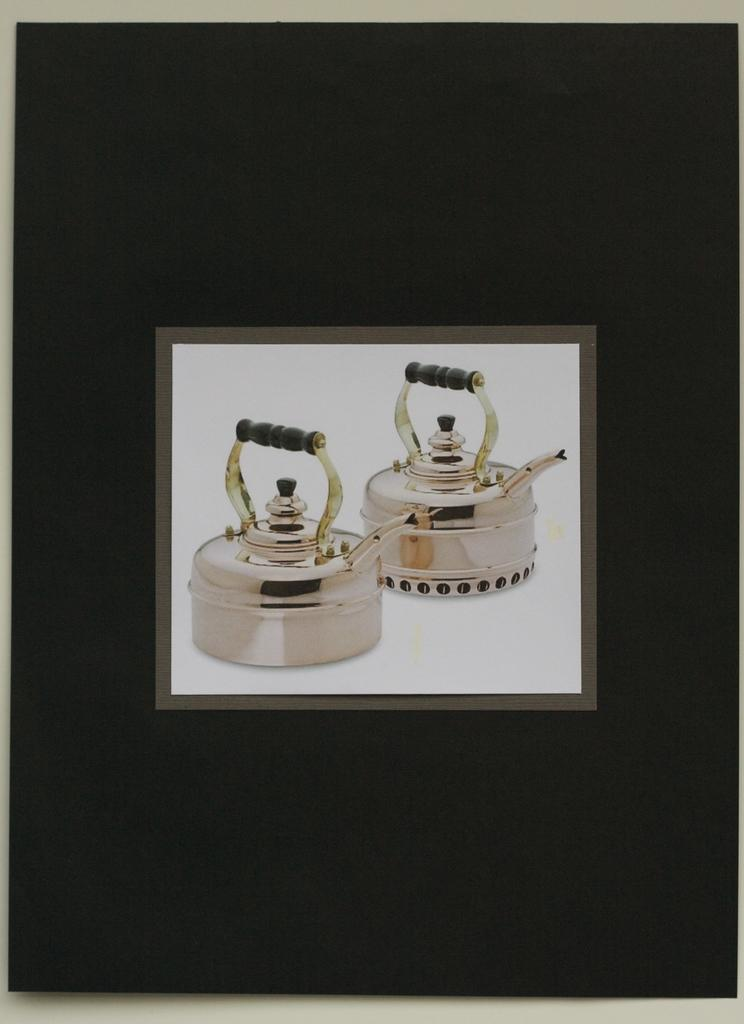What is the main object in the image? There is a blackboard in the image. Where is the blackboard located? The blackboard is attached to a wall. What images are on the blackboard? There are two teapot photos attached to the blackboard. How many mice are hiding behind the blackboard in the image? There are no mice present in the image. What type of agreement is being made in the image? There is no indication of an agreement being made in the image. 